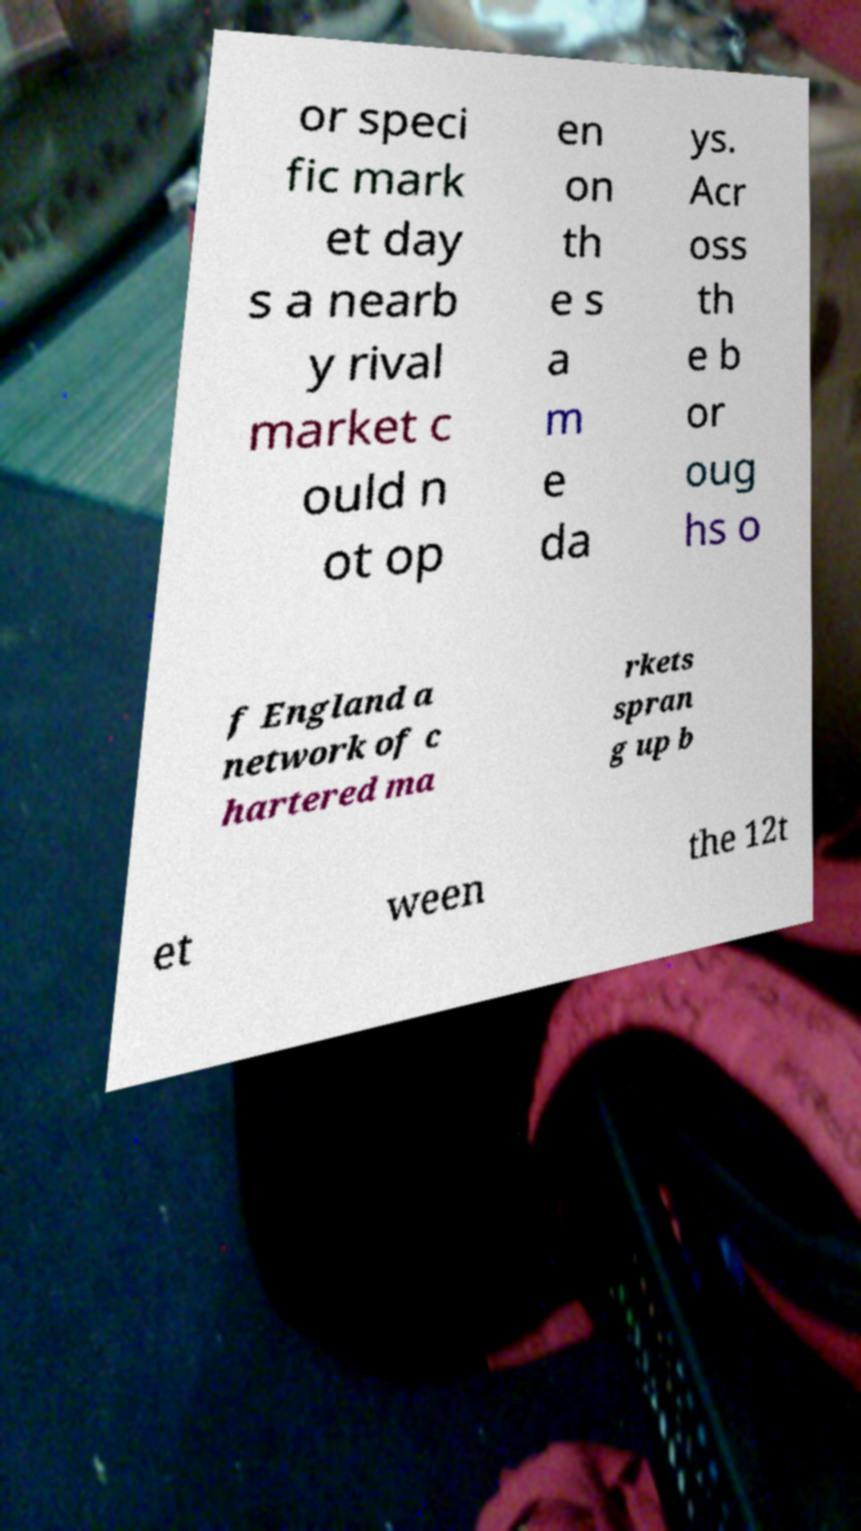For documentation purposes, I need the text within this image transcribed. Could you provide that? or speci fic mark et day s a nearb y rival market c ould n ot op en on th e s a m e da ys. Acr oss th e b or oug hs o f England a network of c hartered ma rkets spran g up b et ween the 12t 